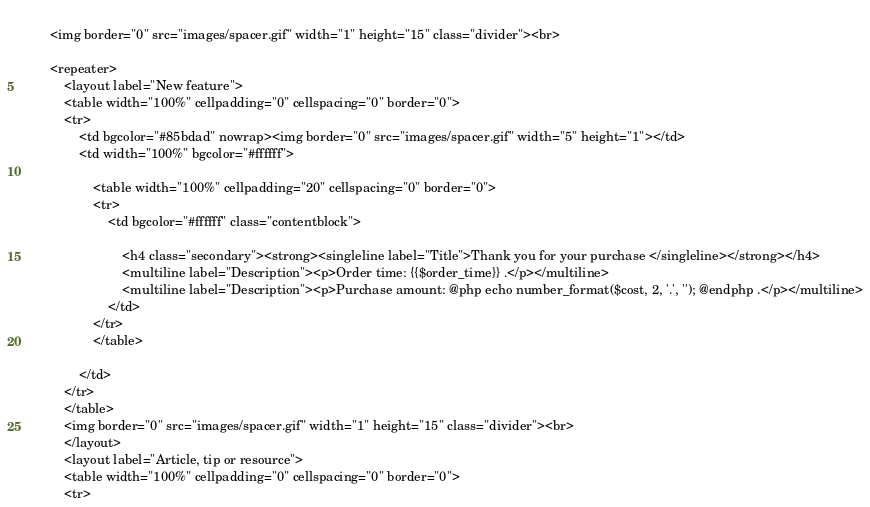<code> <loc_0><loc_0><loc_500><loc_500><_PHP_>	
		<img border="0" src="images/spacer.gif" width="1" height="15" class="divider"><br>
	
		<repeater>
			<layout label="New feature">
			<table width="100%" cellpadding="0" cellspacing="0" border="0">
			<tr>
				<td bgcolor="#85bdad" nowrap><img border="0" src="images/spacer.gif" width="5" height="1"></td>
				<td width="100%" bgcolor="#ffffff">
			
					<table width="100%" cellpadding="20" cellspacing="0" border="0">
					<tr>
						<td bgcolor="#ffffff" class="contentblock">

							<h4 class="secondary"><strong><singleline label="Title">Thank you for your purchase </singleline></strong></h4>
							<multiline label="Description"><p>Order time: {{$order_time}} .</p></multiline>
							<multiline label="Description"><p>Purchase amount: @php echo number_format($cost, 2, '.', ''); @endphp .</p></multiline>
						</td>
					</tr>
					</table>
			
				</td>
			</tr>
			</table>  
			<img border="0" src="images/spacer.gif" width="1" height="15" class="divider"><br>
			</layout>
			<layout label="Article, tip or resource">
			<table width="100%" cellpadding="0" cellspacing="0" border="0">
			<tr></code> 